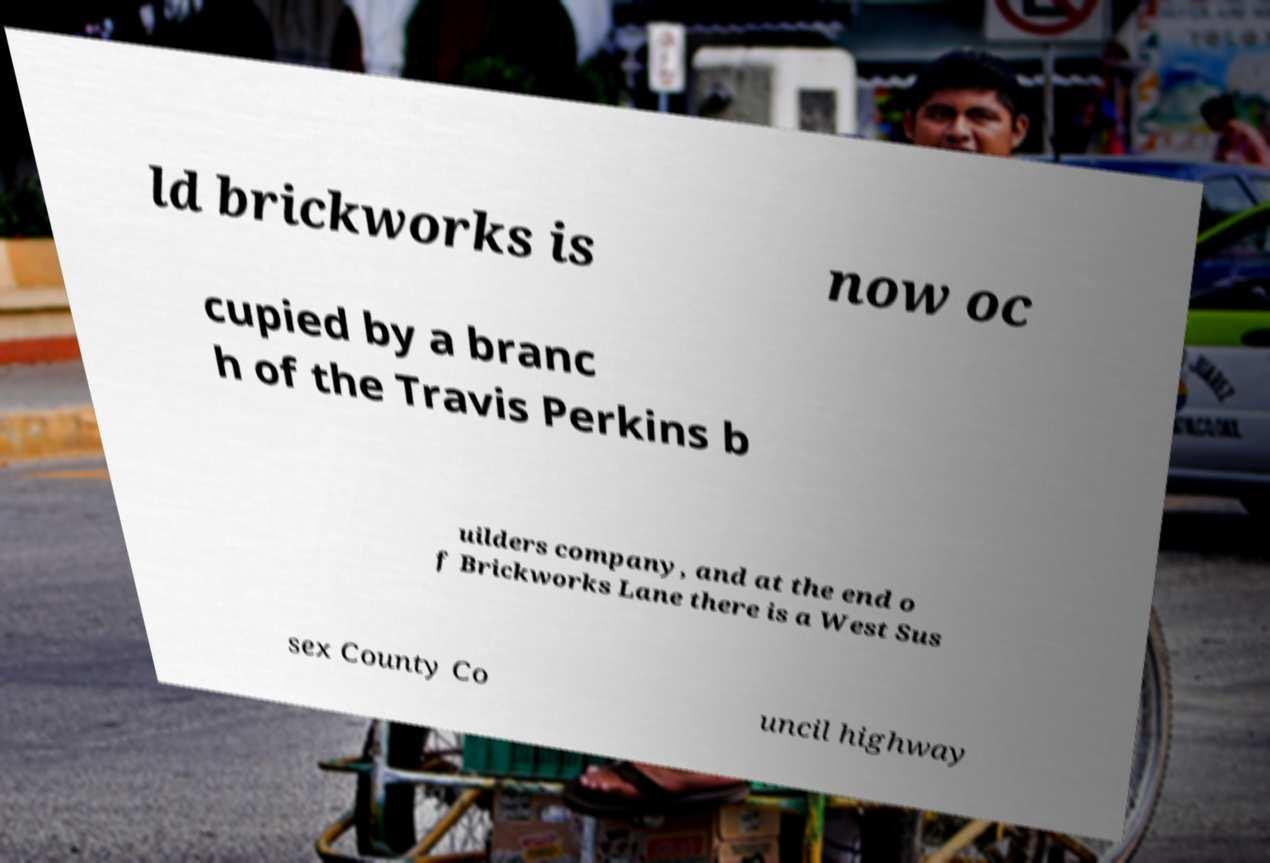Could you assist in decoding the text presented in this image and type it out clearly? ld brickworks is now oc cupied by a branc h of the Travis Perkins b uilders company, and at the end o f Brickworks Lane there is a West Sus sex County Co uncil highway 